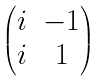Convert formula to latex. <formula><loc_0><loc_0><loc_500><loc_500>\begin{pmatrix} i & - 1 \\ i & 1 \end{pmatrix}</formula> 